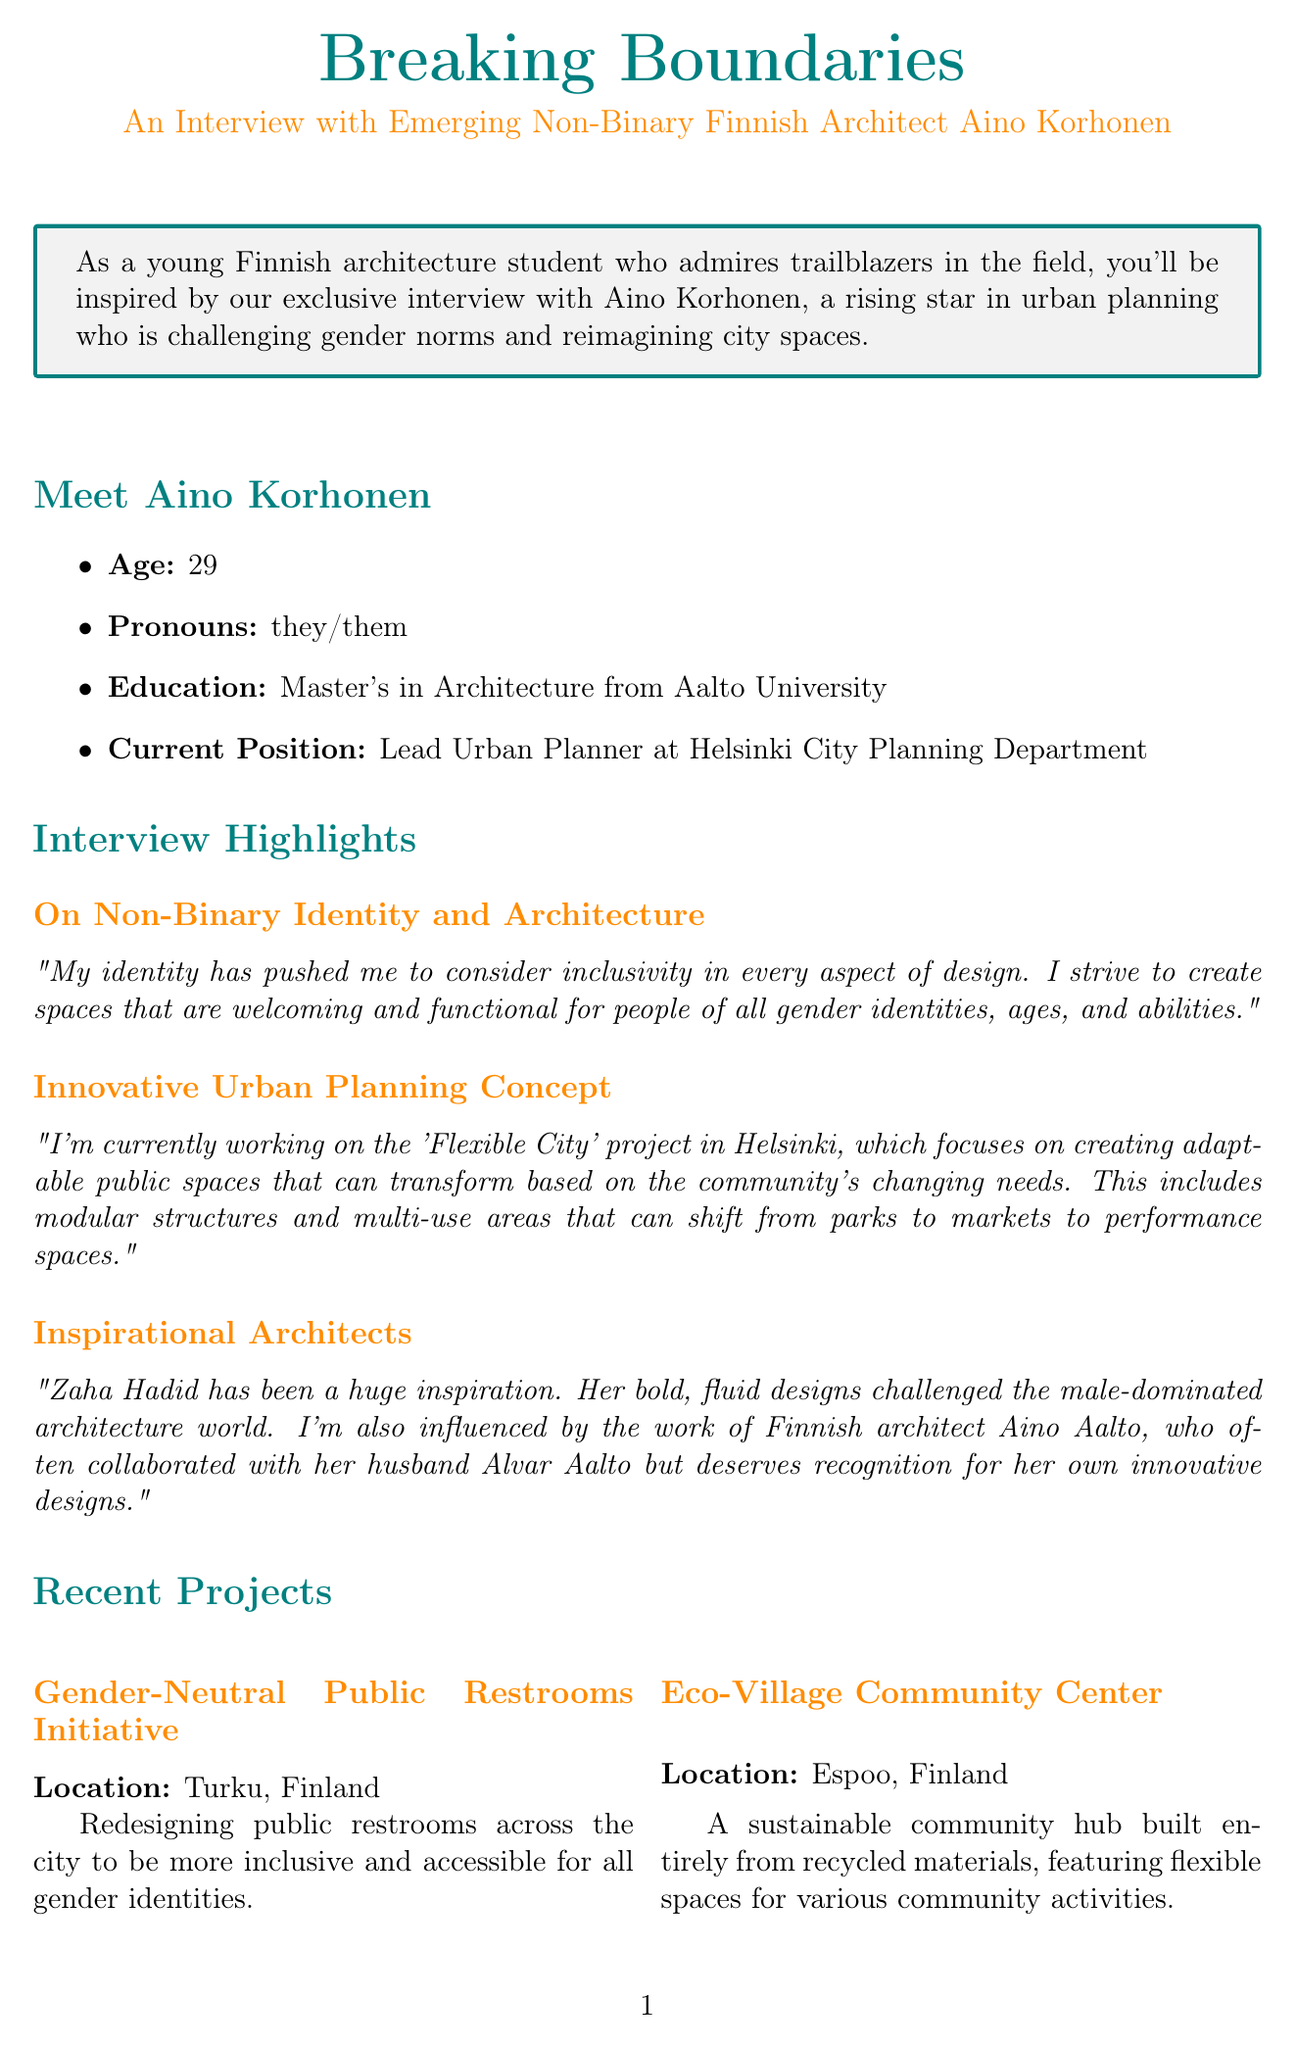What is the name of the architect featured in the interview? The document introduces Aino Korhonen as the featured architect in the interview.
Answer: Aino Korhonen How old is Aino Korhonen? According to the document, Aino Korhonen is 29 years old.
Answer: 29 What is the upcoming project mentioned in the document? The document refers to the "Transformative Housing Complex in Tampere" as the upcoming project.
Answer: Transformative Housing Complex in Tampere Which university did Aino Korhonen attend? Aino Korhonen obtained their Master's in Architecture from Aalto University.
Answer: Aalto University What initiative is being undertaken in Turku, Finland? The document mentions the "Gender-Neutral Public Restrooms Initiative" as the ongoing project in Turku.
Answer: Gender-Neutral Public Restrooms Initiative Who is mentioned as an inspiration for Aino Korhonen? Aino Korhonen mentions Zaha Hadid as a significant inspiration in their approach to architecture.
Answer: Zaha Hadid What is the focus of the "Flexible City" project? The project aims to create adaptable public spaces that transform based on community needs.
Answer: Creating adaptable public spaces Which organization is highlighted in the related resources section? The document lists "Architects for Diversity Finland" as an organization focused on diversity in architecture.
Answer: Architects for Diversity Finland What is the vision Aino Korhonen has for future cities? Aino Korhonen envisions cities where the built environment adapts to the needs of inhabitants.
Answer: Adapting to the needs of inhabitants 